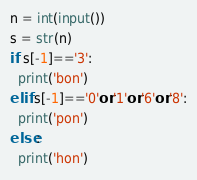Convert code to text. <code><loc_0><loc_0><loc_500><loc_500><_Python_>n = int(input())
s = str(n)
if s[-1]=='3':
  print('bon')
elif s[-1]=='0'or'1'or'6'or'8':
  print('pon')
else:
  print('hon')</code> 